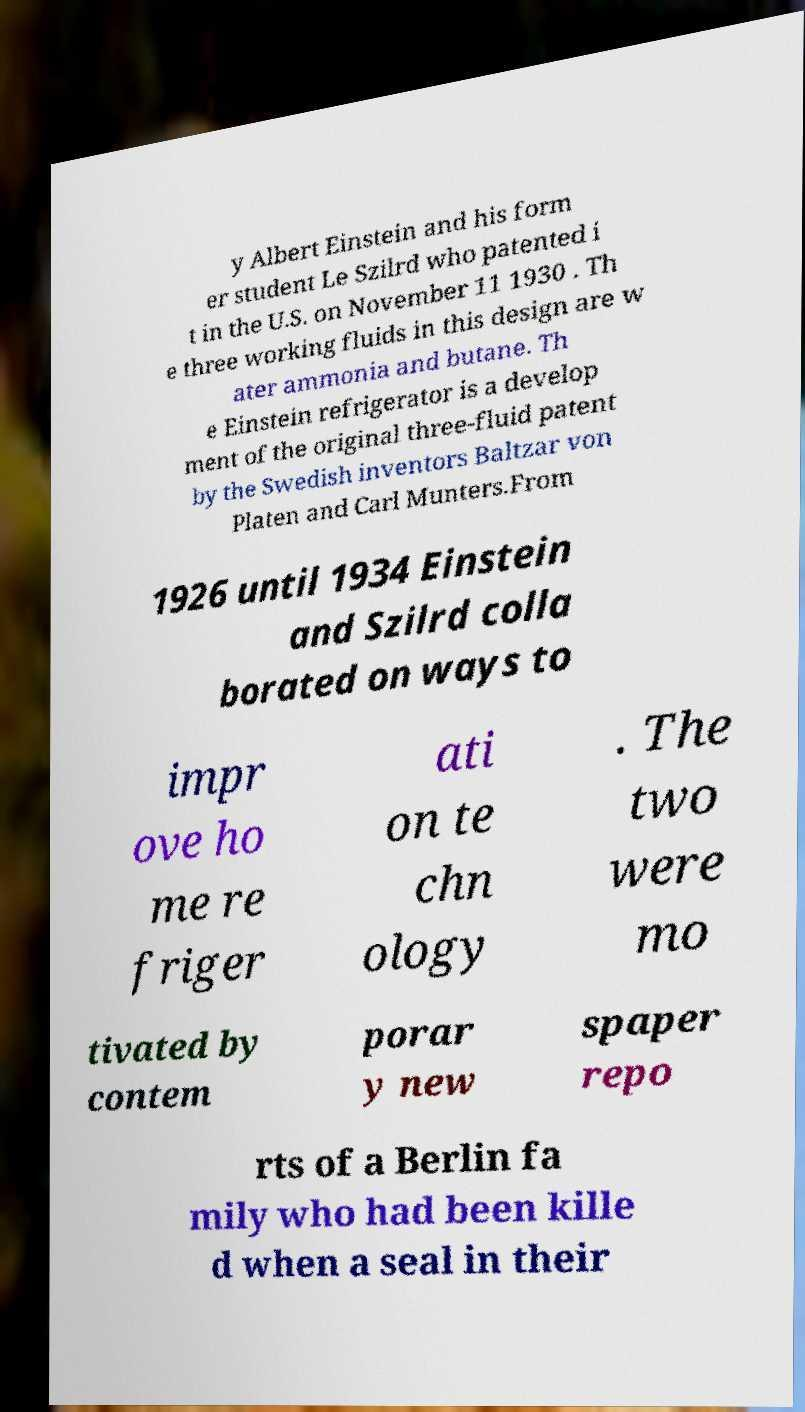What messages or text are displayed in this image? I need them in a readable, typed format. y Albert Einstein and his form er student Le Szilrd who patented i t in the U.S. on November 11 1930 . Th e three working fluids in this design are w ater ammonia and butane. Th e Einstein refrigerator is a develop ment of the original three-fluid patent by the Swedish inventors Baltzar von Platen and Carl Munters.From 1926 until 1934 Einstein and Szilrd colla borated on ways to impr ove ho me re friger ati on te chn ology . The two were mo tivated by contem porar y new spaper repo rts of a Berlin fa mily who had been kille d when a seal in their 